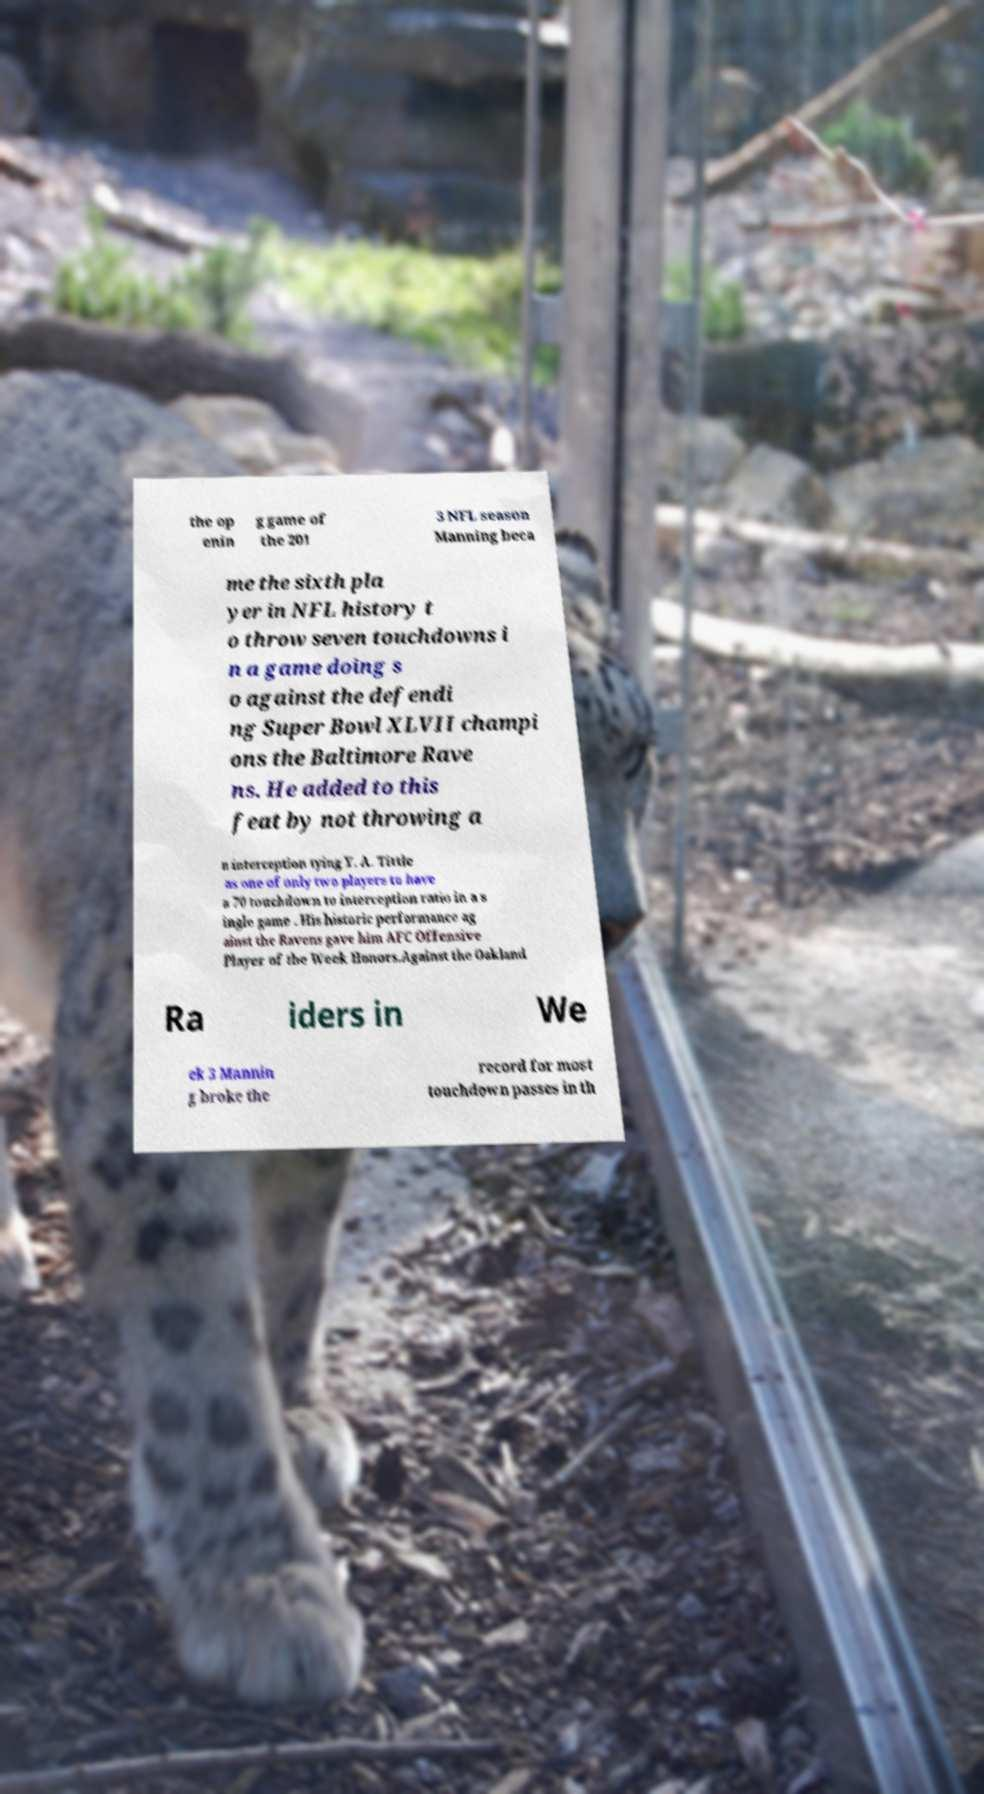For documentation purposes, I need the text within this image transcribed. Could you provide that? the op enin g game of the 201 3 NFL season Manning beca me the sixth pla yer in NFL history t o throw seven touchdowns i n a game doing s o against the defendi ng Super Bowl XLVII champi ons the Baltimore Rave ns. He added to this feat by not throwing a n interception tying Y. A. Tittle as one of only two players to have a 70 touchdown to interception ratio in a s ingle game . His historic performance ag ainst the Ravens gave him AFC Offensive Player of the Week Honors.Against the Oakland Ra iders in We ek 3 Mannin g broke the record for most touchdown passes in th 